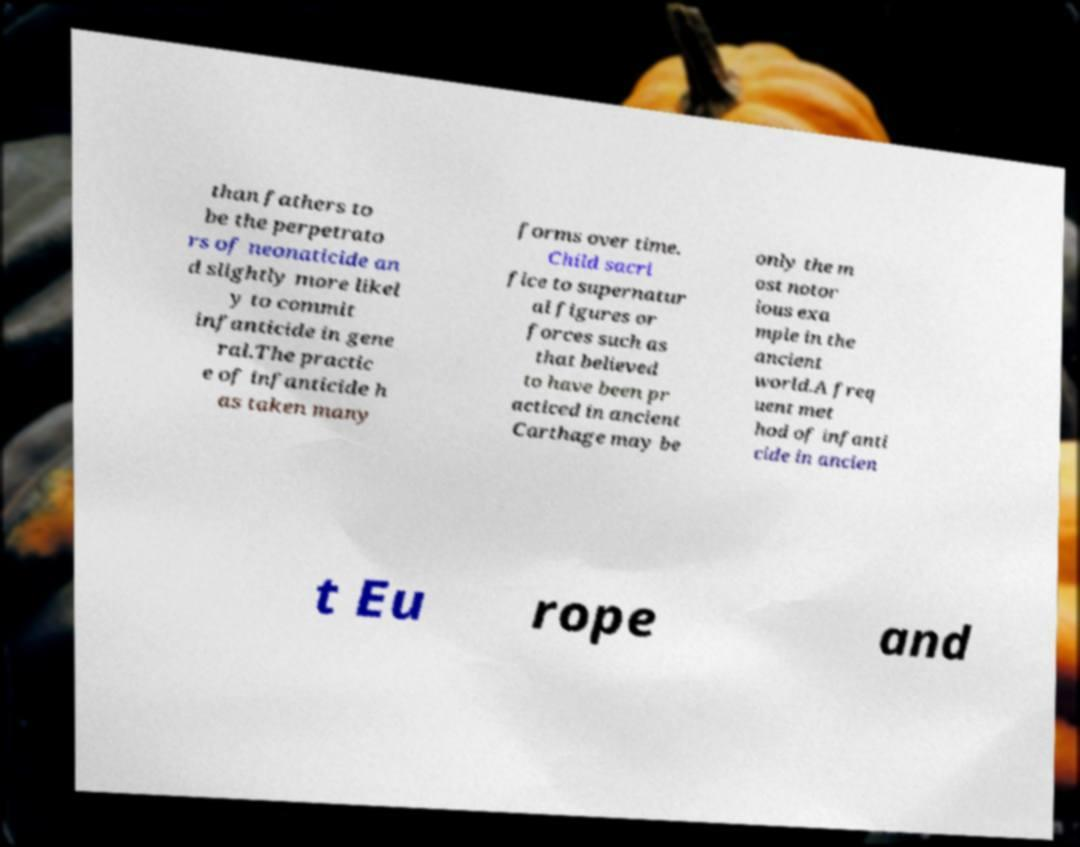Can you read and provide the text displayed in the image?This photo seems to have some interesting text. Can you extract and type it out for me? than fathers to be the perpetrato rs of neonaticide an d slightly more likel y to commit infanticide in gene ral.The practic e of infanticide h as taken many forms over time. Child sacri fice to supernatur al figures or forces such as that believed to have been pr acticed in ancient Carthage may be only the m ost notor ious exa mple in the ancient world.A freq uent met hod of infanti cide in ancien t Eu rope and 